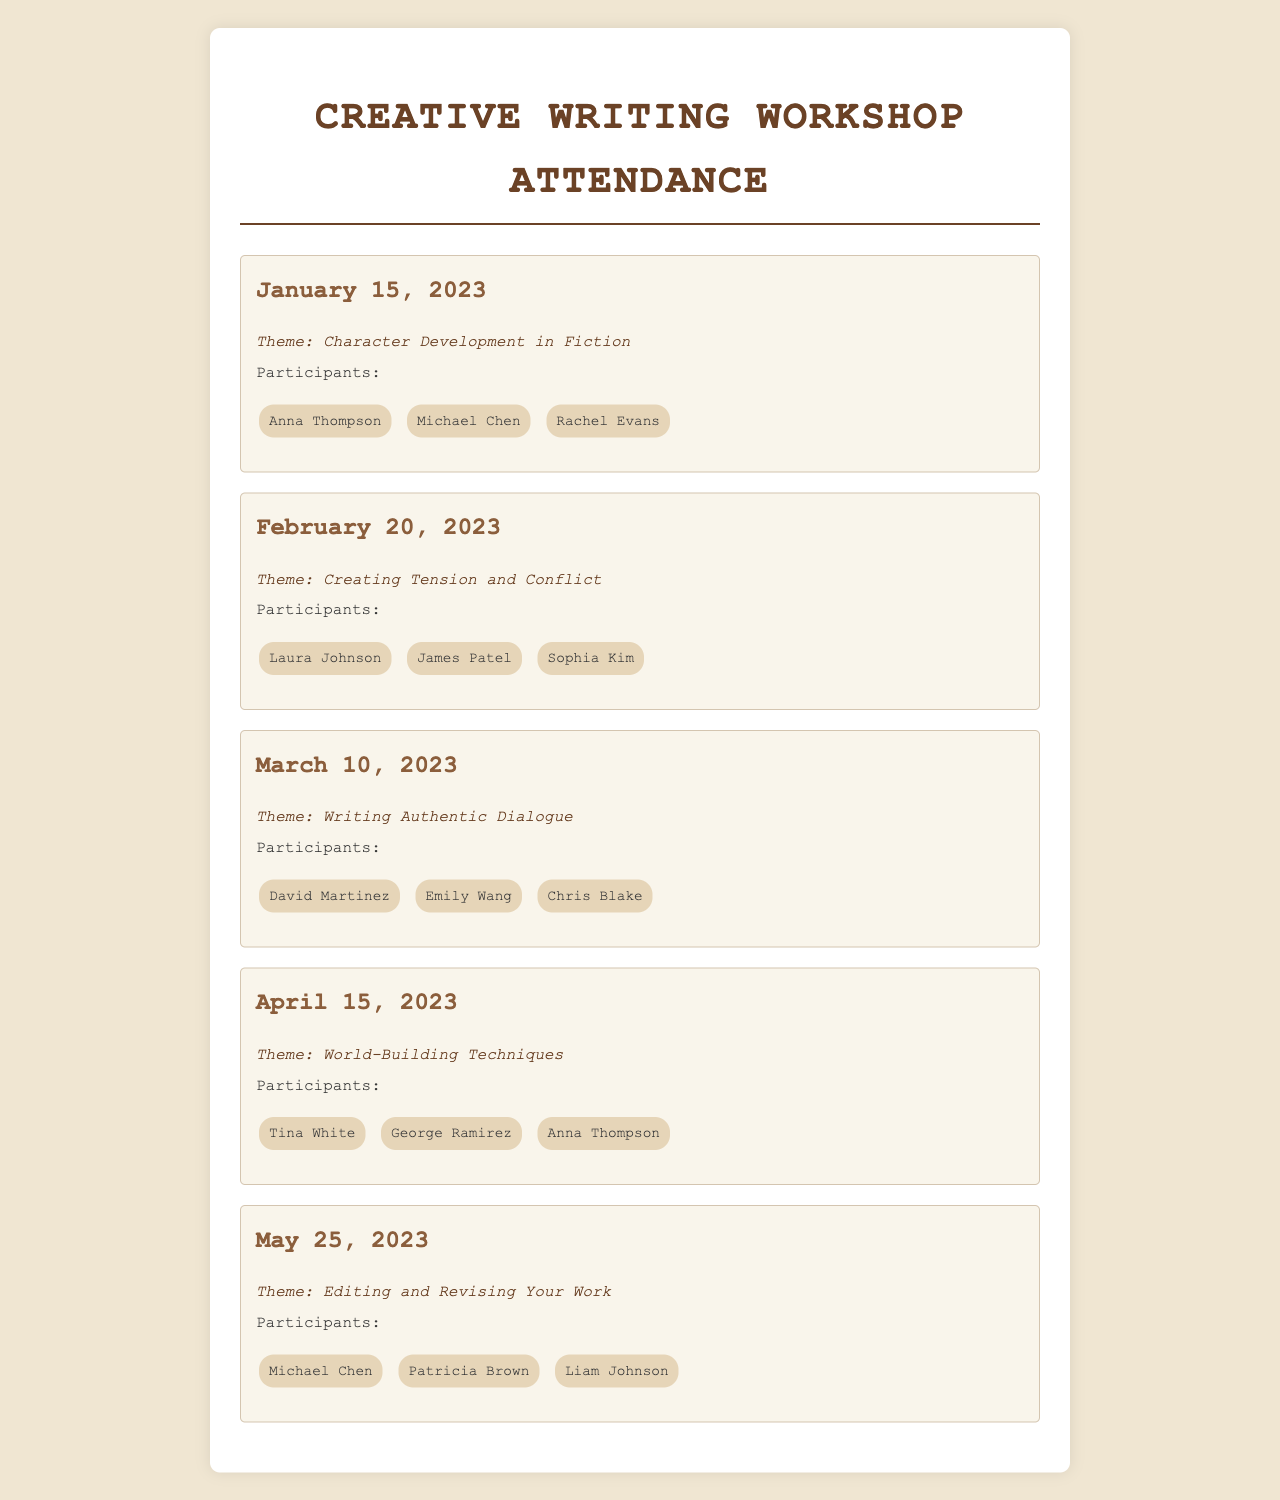What is the theme of the April workshop? The theme of the April workshop is stated under the specific date section as "World-Building Techniques."
Answer: World-Building Techniques How many participants attended the workshop on March 10, 2023? The number of participants is the count of names listed under that workshop's section, which includes three participants: David Martinez, Emily Wang, and Chris Blake.
Answer: 3 Who signed in on January 15, 2023? The names of participants are listed for that date, and they include Anna Thompson, Michael Chen, and Rachel Evans.
Answer: Anna Thompson, Michael Chen, Rachel Evans What is the date of the workshop focused on creating tension? The document lists the date of this workshop, which is February 20, 2023, under its theme of "Creating Tension and Conflict."
Answer: February 20, 2023 Which participant attended the most workshops? To determine this, we check all workshops for repeat names and find that Anna Thompson attended in January and April.
Answer: Anna Thompson What is the theme covered in May? The theme for May 25, 2023, is provided as "Editing and Revising Your Work" under that specific date.
Answer: Editing and Revising Your Work How many workshops discussed character development? The document mentions one workshop that specifically focuses on character development, held on January 15, 2023.
Answer: 1 List the themes covered in the workshops. The document presents a list of themes associated with each workshop date, which includes "Character Development in Fiction," "Creating Tension and Conflict," "Writing Authentic Dialogue," "World-Building Techniques," and "Editing and Revising Your Work."
Answer: Character Development in Fiction, Creating Tension and Conflict, Writing Authentic Dialogue, World-Building Techniques, Editing and Revising Your Work 